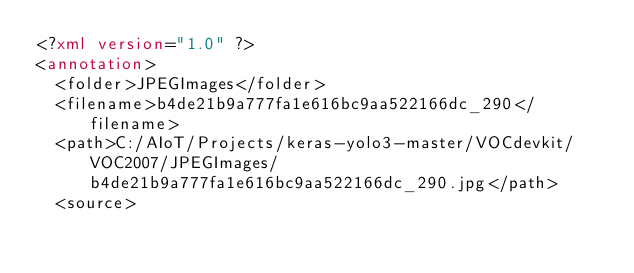Convert code to text. <code><loc_0><loc_0><loc_500><loc_500><_XML_><?xml version="1.0" ?>
<annotation>
	<folder>JPEGImages</folder>
	<filename>b4de21b9a777fa1e616bc9aa522166dc_290</filename>
	<path>C:/AIoT/Projects/keras-yolo3-master/VOCdevkit/VOC2007/JPEGImages/b4de21b9a777fa1e616bc9aa522166dc_290.jpg</path>
	<source></code> 